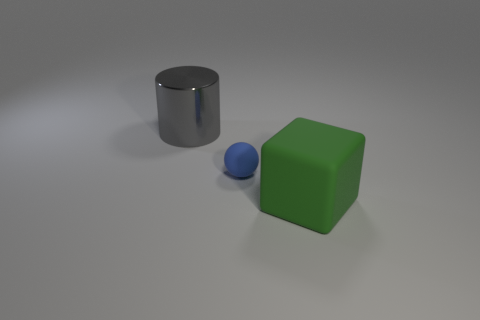Add 3 big green cubes. How many objects exist? 6 Subtract all balls. How many objects are left? 2 Add 3 large green objects. How many large green objects exist? 4 Subtract 0 yellow blocks. How many objects are left? 3 Subtract all gray things. Subtract all big cylinders. How many objects are left? 1 Add 2 large green blocks. How many large green blocks are left? 3 